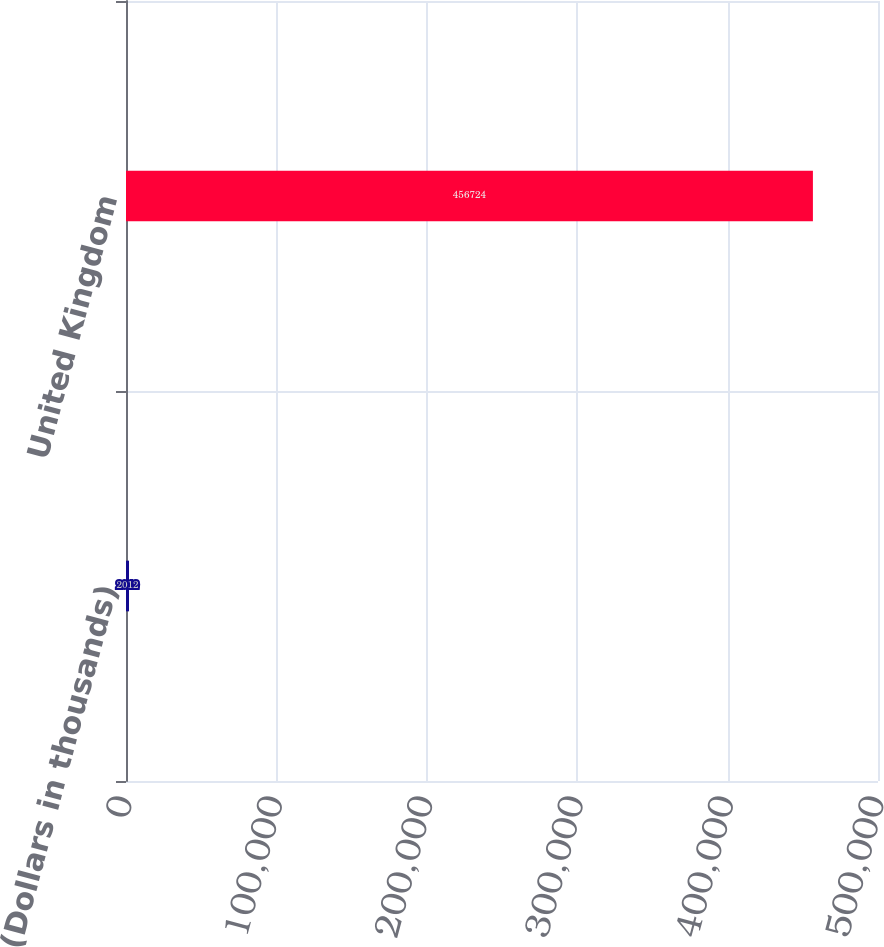Convert chart. <chart><loc_0><loc_0><loc_500><loc_500><bar_chart><fcel>(Dollars in thousands)<fcel>United Kingdom<nl><fcel>2012<fcel>456724<nl></chart> 